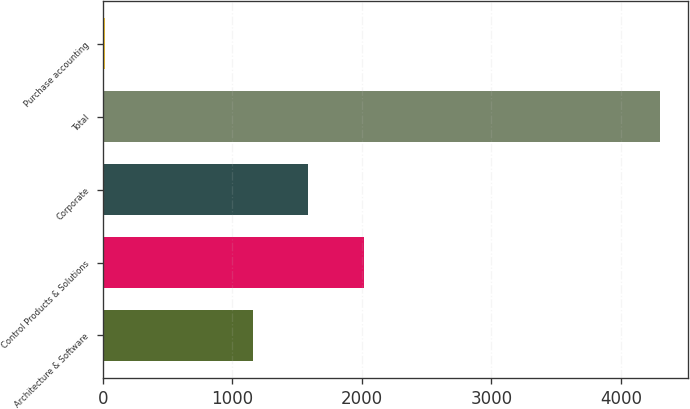Convert chart to OTSL. <chart><loc_0><loc_0><loc_500><loc_500><bar_chart><fcel>Architecture & Software<fcel>Control Products & Solutions<fcel>Corporate<fcel>Total<fcel>Purchase accounting<nl><fcel>1157.2<fcel>2014.62<fcel>1585.91<fcel>4305.7<fcel>18.6<nl></chart> 